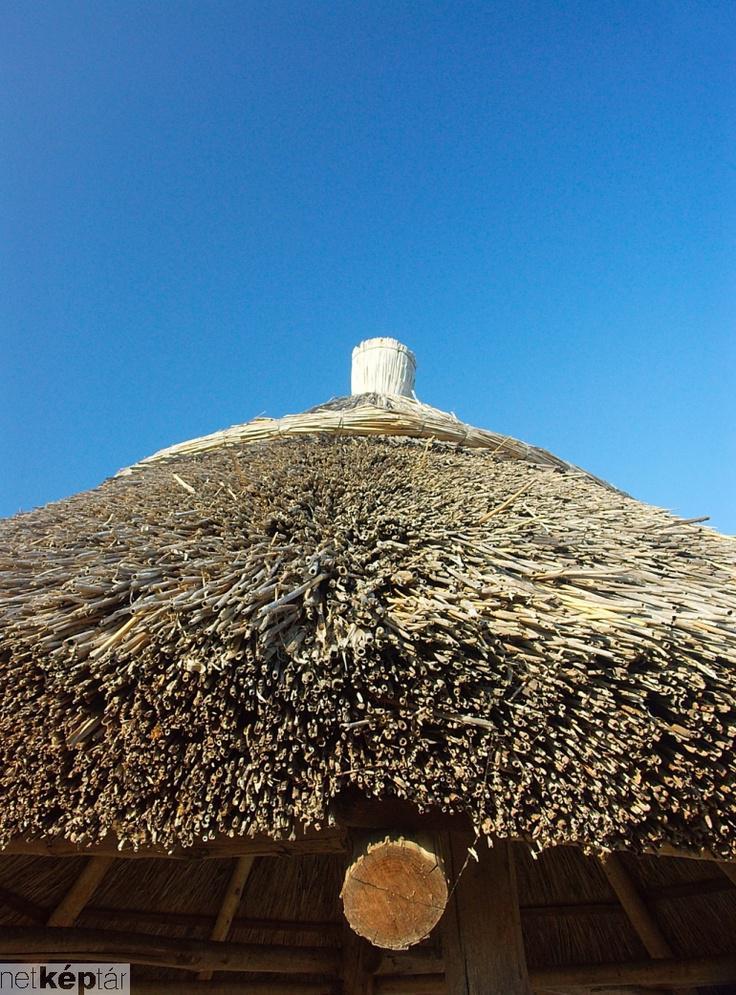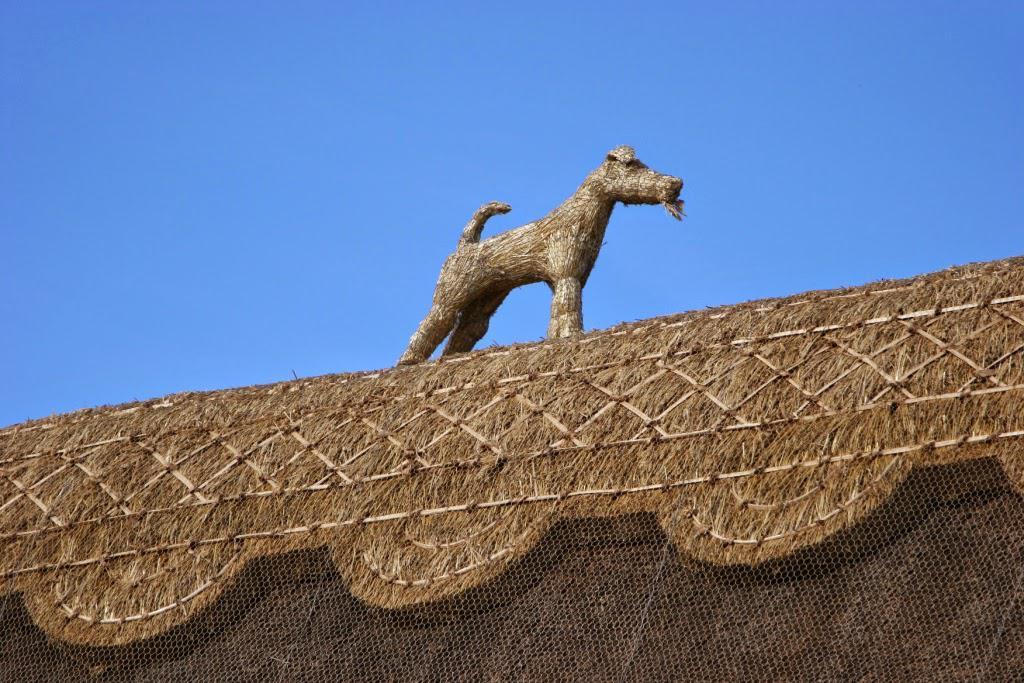The first image is the image on the left, the second image is the image on the right. For the images shown, is this caption "At least one animal is standing on the roof in the image on the right." true? Answer yes or no. Yes. The first image is the image on the left, the second image is the image on the right. Considering the images on both sides, is "The left image features a simple peaked thatch roof with a small projection at the top, and the right image features at least one animal figure on the edge of a peaked roof with diamond 'stitched' border." valid? Answer yes or no. Yes. 